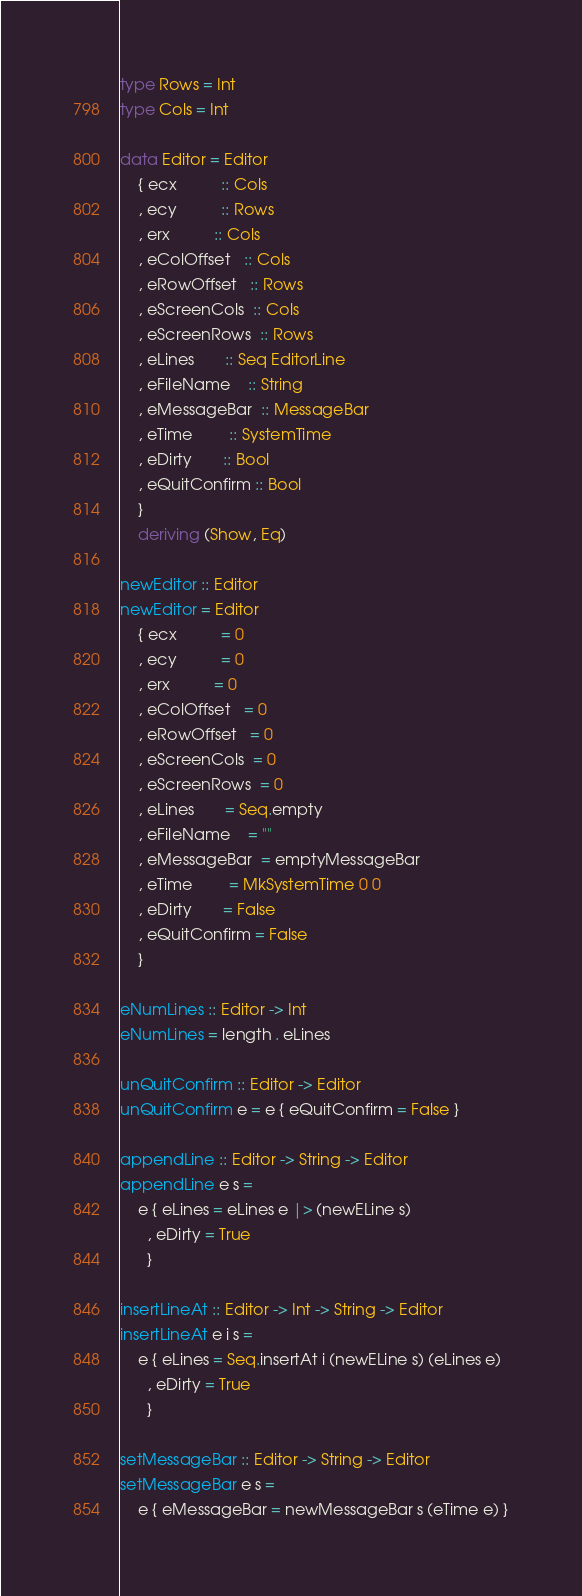<code> <loc_0><loc_0><loc_500><loc_500><_Haskell_>type Rows = Int
type Cols = Int

data Editor = Editor
    { ecx          :: Cols
    , ecy          :: Rows
    , erx          :: Cols
    , eColOffset   :: Cols
    , eRowOffset   :: Rows
    , eScreenCols  :: Cols
    , eScreenRows  :: Rows
    , eLines       :: Seq EditorLine
    , eFileName    :: String
    , eMessageBar  :: MessageBar
    , eTime        :: SystemTime
    , eDirty       :: Bool
    , eQuitConfirm :: Bool
    }
    deriving (Show, Eq)

newEditor :: Editor
newEditor = Editor
    { ecx          = 0
    , ecy          = 0
    , erx          = 0
    , eColOffset   = 0
    , eRowOffset   = 0
    , eScreenCols  = 0
    , eScreenRows  = 0
    , eLines       = Seq.empty
    , eFileName    = ""
    , eMessageBar  = emptyMessageBar
    , eTime        = MkSystemTime 0 0
    , eDirty       = False
    , eQuitConfirm = False
    }

eNumLines :: Editor -> Int
eNumLines = length . eLines

unQuitConfirm :: Editor -> Editor
unQuitConfirm e = e { eQuitConfirm = False }

appendLine :: Editor -> String -> Editor
appendLine e s =
    e { eLines = eLines e |> (newELine s)
      , eDirty = True
      }

insertLineAt :: Editor -> Int -> String -> Editor
insertLineAt e i s =
    e { eLines = Seq.insertAt i (newELine s) (eLines e)
      , eDirty = True
      }

setMessageBar :: Editor -> String -> Editor
setMessageBar e s =
    e { eMessageBar = newMessageBar s (eTime e) }
</code> 